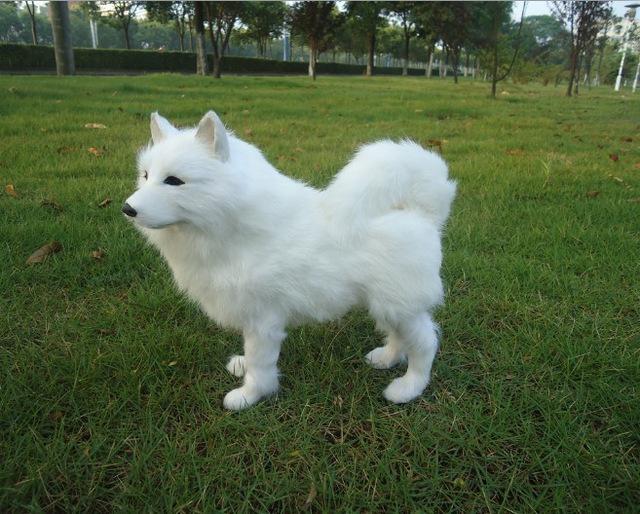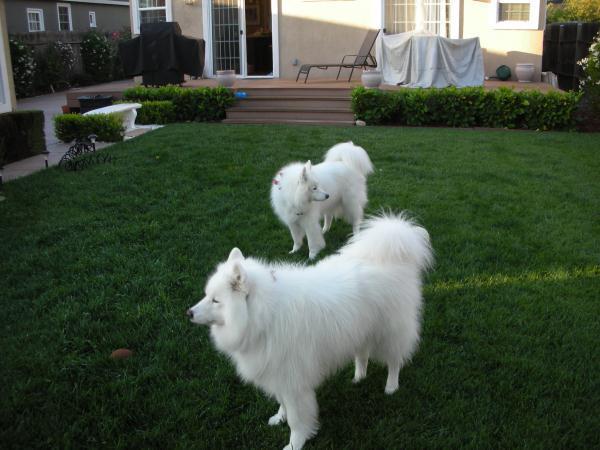The first image is the image on the left, the second image is the image on the right. For the images shown, is this caption "there is a dog standing on the grass with a row of trees behind it" true? Answer yes or no. Yes. The first image is the image on the left, the second image is the image on the right. Given the left and right images, does the statement "Two dogs are in a grassy area in the image on the right." hold true? Answer yes or no. Yes. 